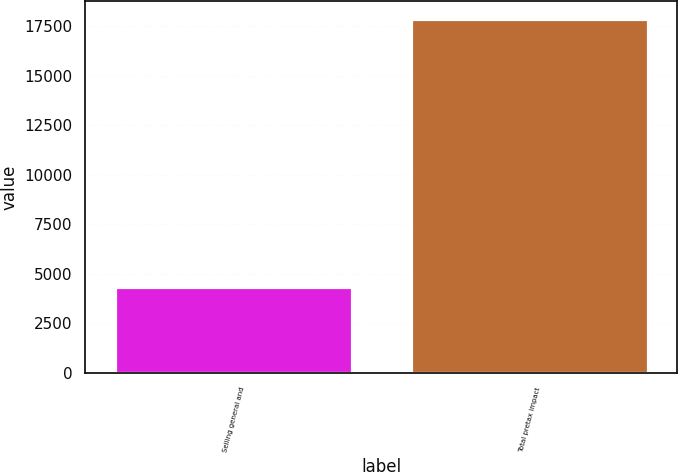<chart> <loc_0><loc_0><loc_500><loc_500><bar_chart><fcel>Selling general and<fcel>Total pretax impact<nl><fcel>4325<fcel>17852<nl></chart> 